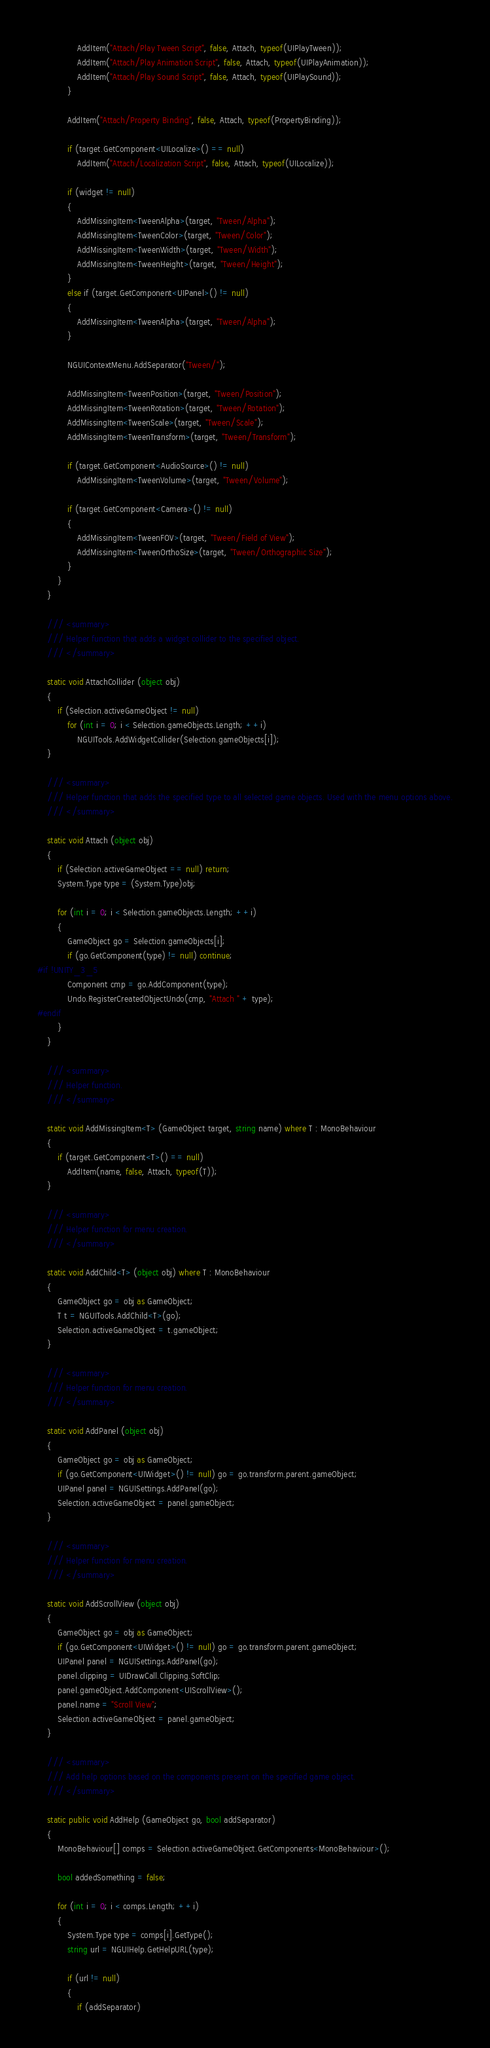<code> <loc_0><loc_0><loc_500><loc_500><_C#_>				AddItem("Attach/Play Tween Script", false, Attach, typeof(UIPlayTween));
				AddItem("Attach/Play Animation Script", false, Attach, typeof(UIPlayAnimation));
				AddItem("Attach/Play Sound Script", false, Attach, typeof(UIPlaySound));
			}

			AddItem("Attach/Property Binding", false, Attach, typeof(PropertyBinding));

			if (target.GetComponent<UILocalize>() == null)
				AddItem("Attach/Localization Script", false, Attach, typeof(UILocalize));

			if (widget != null)
			{
				AddMissingItem<TweenAlpha>(target, "Tween/Alpha");
				AddMissingItem<TweenColor>(target, "Tween/Color");
				AddMissingItem<TweenWidth>(target, "Tween/Width");
				AddMissingItem<TweenHeight>(target, "Tween/Height");
			}
			else if (target.GetComponent<UIPanel>() != null)
			{
				AddMissingItem<TweenAlpha>(target, "Tween/Alpha");
			}

			NGUIContextMenu.AddSeparator("Tween/");

			AddMissingItem<TweenPosition>(target, "Tween/Position");
			AddMissingItem<TweenRotation>(target, "Tween/Rotation");
			AddMissingItem<TweenScale>(target, "Tween/Scale");
			AddMissingItem<TweenTransform>(target, "Tween/Transform");

			if (target.GetComponent<AudioSource>() != null)
				AddMissingItem<TweenVolume>(target, "Tween/Volume");

			if (target.GetComponent<Camera>() != null)
			{
				AddMissingItem<TweenFOV>(target, "Tween/Field of View");
				AddMissingItem<TweenOrthoSize>(target, "Tween/Orthographic Size");
			}
		}
	}

	/// <summary>
	/// Helper function that adds a widget collider to the specified object.
	/// </summary>

	static void AttachCollider (object obj)
	{
		if (Selection.activeGameObject != null)
			for (int i = 0; i < Selection.gameObjects.Length; ++i)
				NGUITools.AddWidgetCollider(Selection.gameObjects[i]);
	}

	/// <summary>
	/// Helper function that adds the specified type to all selected game objects. Used with the menu options above.
	/// </summary>

	static void Attach (object obj)
	{
		if (Selection.activeGameObject == null) return;
		System.Type type = (System.Type)obj;

		for (int i = 0; i < Selection.gameObjects.Length; ++i)
		{
			GameObject go = Selection.gameObjects[i];
			if (go.GetComponent(type) != null) continue;
#if !UNITY_3_5
			Component cmp = go.AddComponent(type);
			Undo.RegisterCreatedObjectUndo(cmp, "Attach " + type);
#endif
		}
	}

	/// <summary>
	/// Helper function.
	/// </summary>

	static void AddMissingItem<T> (GameObject target, string name) where T : MonoBehaviour
	{
		if (target.GetComponent<T>() == null)
			AddItem(name, false, Attach, typeof(T));
	}

	/// <summary>
	/// Helper function for menu creation.
	/// </summary>

	static void AddChild<T> (object obj) where T : MonoBehaviour
	{
		GameObject go = obj as GameObject;
		T t = NGUITools.AddChild<T>(go);
		Selection.activeGameObject = t.gameObject;
	}

	/// <summary>
	/// Helper function for menu creation.
	/// </summary>

	static void AddPanel (object obj)
	{
		GameObject go = obj as GameObject;
		if (go.GetComponent<UIWidget>() != null) go = go.transform.parent.gameObject;
		UIPanel panel = NGUISettings.AddPanel(go);
		Selection.activeGameObject = panel.gameObject;
	}

	/// <summary>
	/// Helper function for menu creation.
	/// </summary>

	static void AddScrollView (object obj)
	{
		GameObject go = obj as GameObject;
		if (go.GetComponent<UIWidget>() != null) go = go.transform.parent.gameObject;
		UIPanel panel = NGUISettings.AddPanel(go);
		panel.clipping = UIDrawCall.Clipping.SoftClip;
		panel.gameObject.AddComponent<UIScrollView>();
		panel.name = "Scroll View";
		Selection.activeGameObject = panel.gameObject;
	}

	/// <summary>
	/// Add help options based on the components present on the specified game object.
	/// </summary>

	static public void AddHelp (GameObject go, bool addSeparator)
	{
		MonoBehaviour[] comps = Selection.activeGameObject.GetComponents<MonoBehaviour>();

		bool addedSomething = false;

		for (int i = 0; i < comps.Length; ++i)
		{
			System.Type type = comps[i].GetType();
			string url = NGUIHelp.GetHelpURL(type);
			
			if (url != null)
			{
				if (addSeparator)</code> 